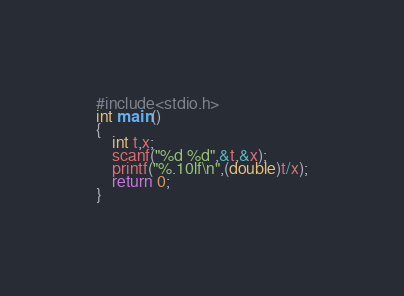Convert code to text. <code><loc_0><loc_0><loc_500><loc_500><_C_>#include<stdio.h>
int main()
{
    int t,x;
    scanf("%d %d",&t,&x);
    printf("%.10lf\n",(double)t/x);
    return 0;
}</code> 